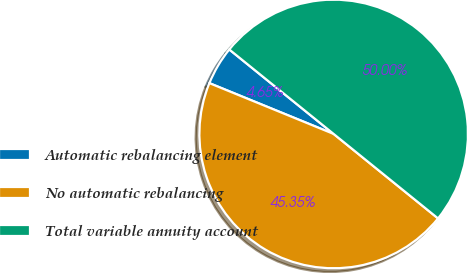Convert chart to OTSL. <chart><loc_0><loc_0><loc_500><loc_500><pie_chart><fcel>Automatic rebalancing element<fcel>No automatic rebalancing<fcel>Total variable annuity account<nl><fcel>4.65%<fcel>45.35%<fcel>50.0%<nl></chart> 